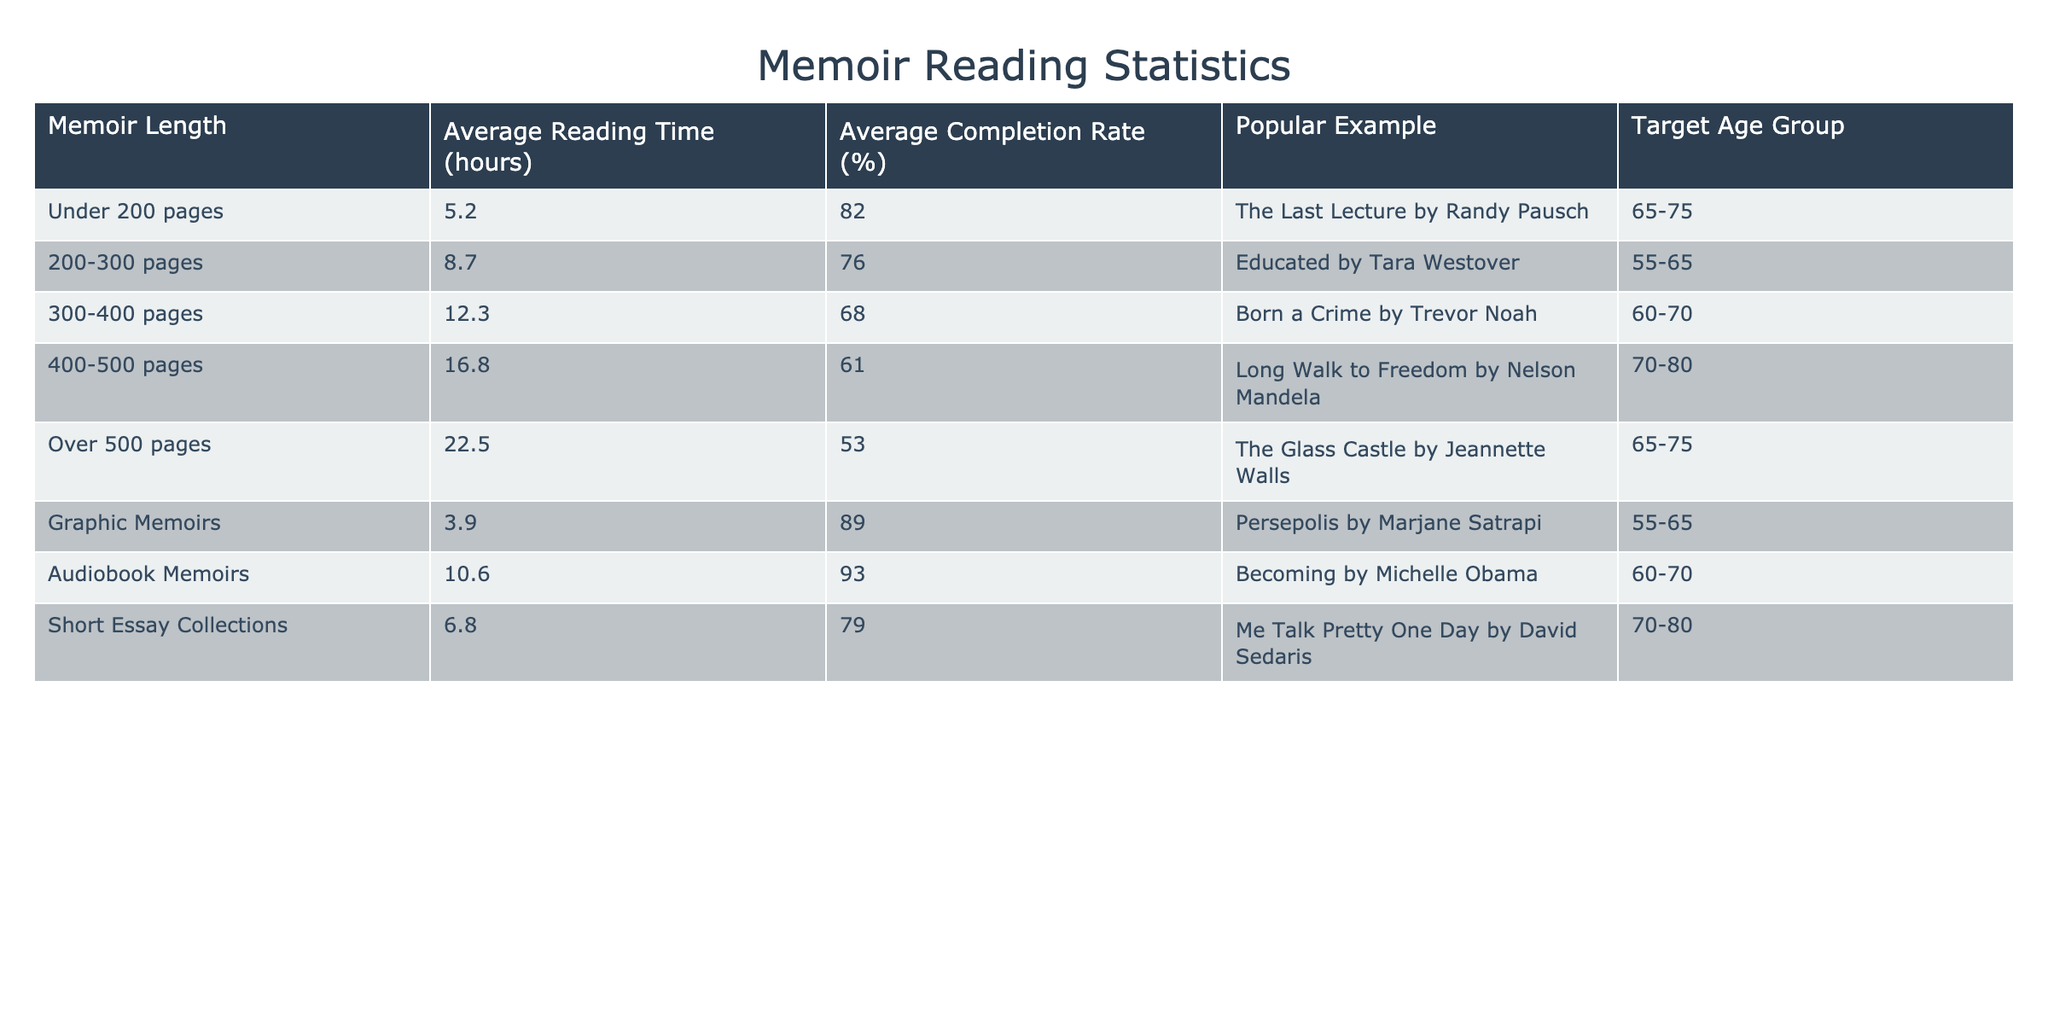What is the average reading time for memoirs over 500 pages? The table states that the average reading time for memoirs over 500 pages is 22.5 hours.
Answer: 22.5 hours Which memoir has the highest average completion rate? The memoir titled "Persepolis" has the highest average completion rate at 89%.
Answer: 89% How does the average reading time for graphic memoirs compare to that for short essay collections? The average reading time for graphic memoirs is 3.9 hours and for short essay collections is 6.8 hours; 6.8 - 3.9 equals 2.9 hours, meaning short essay collections take 2.9 hours longer on average.
Answer: 2.9 hours longer Is the average completion rate for memoirs between 300-400 pages above 70%? The average completion rate for memoirs in this length category is 68%, which is below 70%.
Answer: No What is the average reading time for memoirs that are 200-500 pages long? The average reading times are 8.7 hours (200-300), 12.3 hours (300-400), and 16.8 hours (400-500). First, sum these values: 8.7 + 12.3 + 16.8 = 37.8 hours. Then, divide by the number of entries, which is 3: 37.8 / 3 = 12.6 hours.
Answer: 12.6 hours Which target age group has the lowest average completion rate? For memoirs over 500 pages, the average completion rate is 53%, which is the lowest compared to the others.
Answer: 65-75 If I compare the reading times of audiobooks and graphic memoirs, which is longer? The average reading time for audiobooks is 10.6 hours, and for graphic memoirs, it is 3.9 hours. Since 10.6 is greater than 3.9, audiobooks take longer to read.
Answer: Audiobook memoirs are longer What is the difference in average reading time between the shortest and longest memoir lengths? The shortest memoir length is graphic memoirs at 3.9 hours, and the longest is memoirs over 500 pages at 22.5 hours. The difference is 22.5 - 3.9 = 18.6 hours.
Answer: 18.6 hours What percentage of readers complete memoirs under 200 pages? The average completion rate for memoirs under 200 pages is 82%, according to the data in the table.
Answer: 82% What memoir length category has the highest average reading time? The period for memoirs over 500 pages has the highest average reading time at 22.5 hours, the table indicates.
Answer: Over 500 pages 